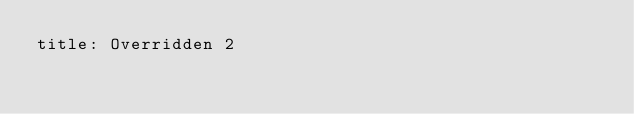<code> <loc_0><loc_0><loc_500><loc_500><_YAML_>title: Overridden 2</code> 